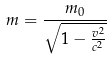Convert formula to latex. <formula><loc_0><loc_0><loc_500><loc_500>m = \frac { m _ { 0 } } { \sqrt { 1 - \frac { v ^ { 2 } } { c ^ { 2 } } } }</formula> 